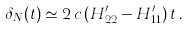<formula> <loc_0><loc_0><loc_500><loc_500>\delta _ { N } ( t ) \simeq 2 \, c \, ( H _ { 2 2 } ^ { \prime } - H _ { 1 1 } ^ { \prime } ) \, t \, .</formula> 